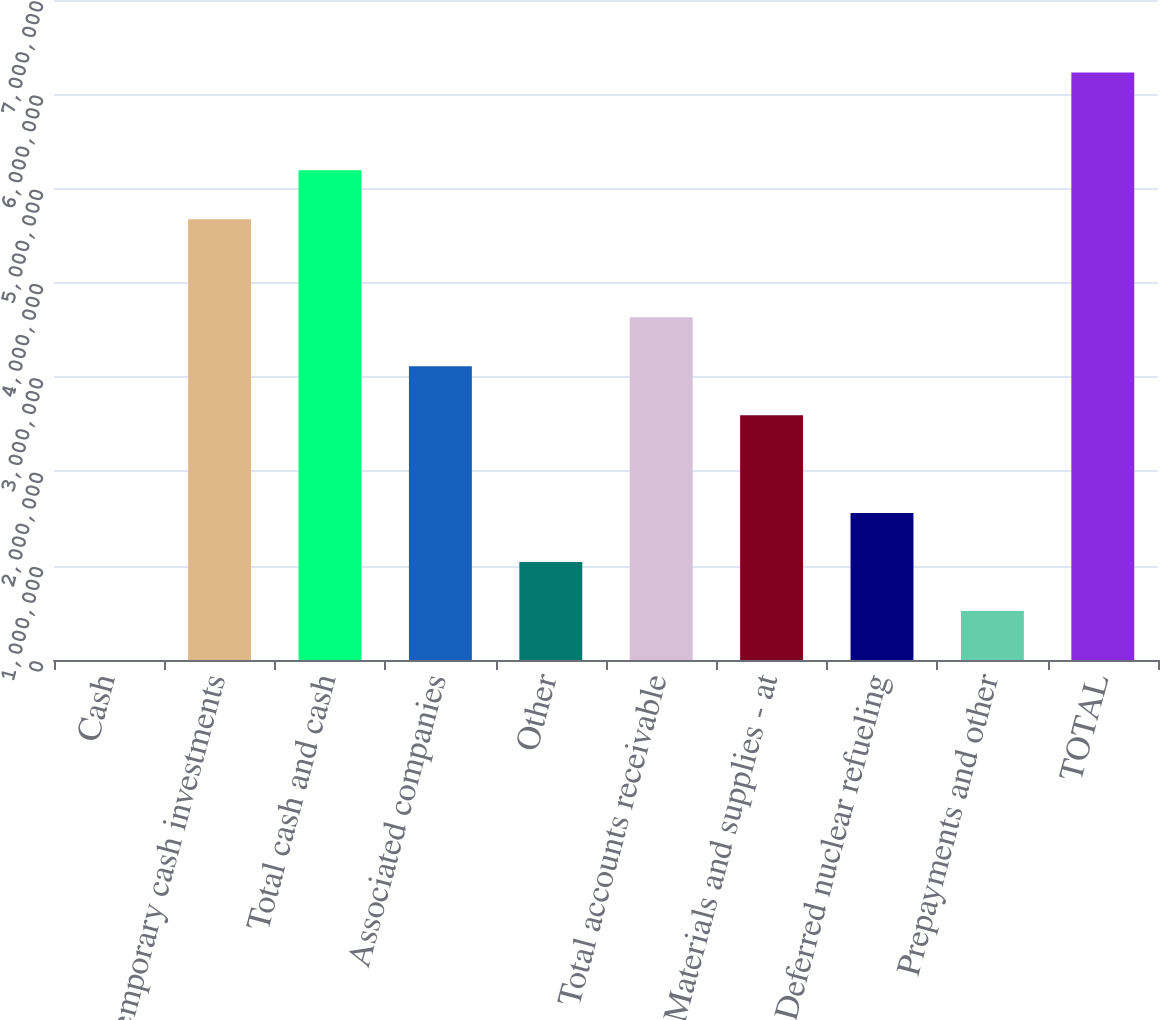Convert chart to OTSL. <chart><loc_0><loc_0><loc_500><loc_500><bar_chart><fcel>Cash<fcel>Temporary cash investments<fcel>Total cash and cash<fcel>Associated companies<fcel>Other<fcel>Total accounts receivable<fcel>Materials and supplies - at<fcel>Deferred nuclear refueling<fcel>Prepayments and other<fcel>TOTAL<nl><fcel>78<fcel>4.67423e+06<fcel>5.19358e+06<fcel>3.11618e+06<fcel>1.03878e+06<fcel>3.63553e+06<fcel>2.59683e+06<fcel>1.55813e+06<fcel>519428<fcel>6.23228e+06<nl></chart> 